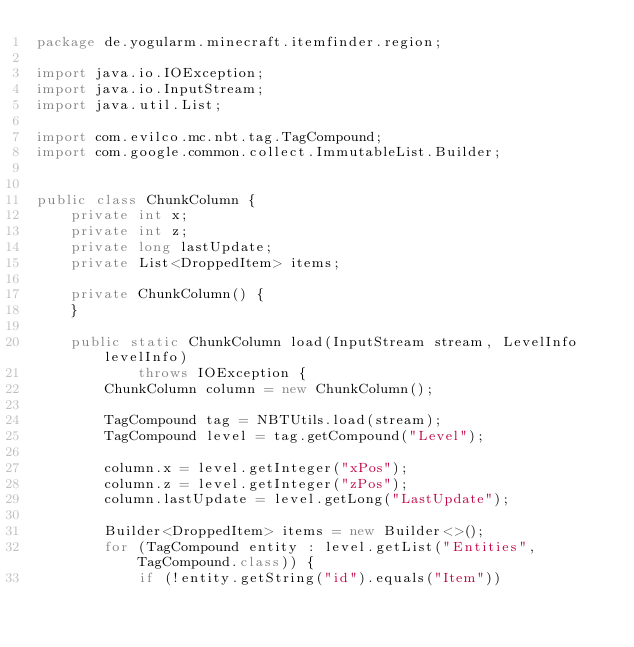<code> <loc_0><loc_0><loc_500><loc_500><_Java_>package de.yogularm.minecraft.itemfinder.region;

import java.io.IOException;
import java.io.InputStream;
import java.util.List;

import com.evilco.mc.nbt.tag.TagCompound;
import com.google.common.collect.ImmutableList.Builder;


public class ChunkColumn {
	private int x;
	private int z;
	private long lastUpdate;
	private List<DroppedItem> items;
	
	private ChunkColumn() {
	}
	
	public static ChunkColumn load(InputStream stream, LevelInfo levelInfo)
			throws IOException {
		ChunkColumn column = new ChunkColumn();
		
		TagCompound tag = NBTUtils.load(stream);
		TagCompound level = tag.getCompound("Level");
		
		column.x = level.getInteger("xPos");
		column.z = level.getInteger("zPos");
		column.lastUpdate = level.getLong("LastUpdate");
		
		Builder<DroppedItem> items = new Builder<>();
		for (TagCompound entity : level.getList("Entities", TagCompound.class)) {
			if (!entity.getString("id").equals("Item"))</code> 